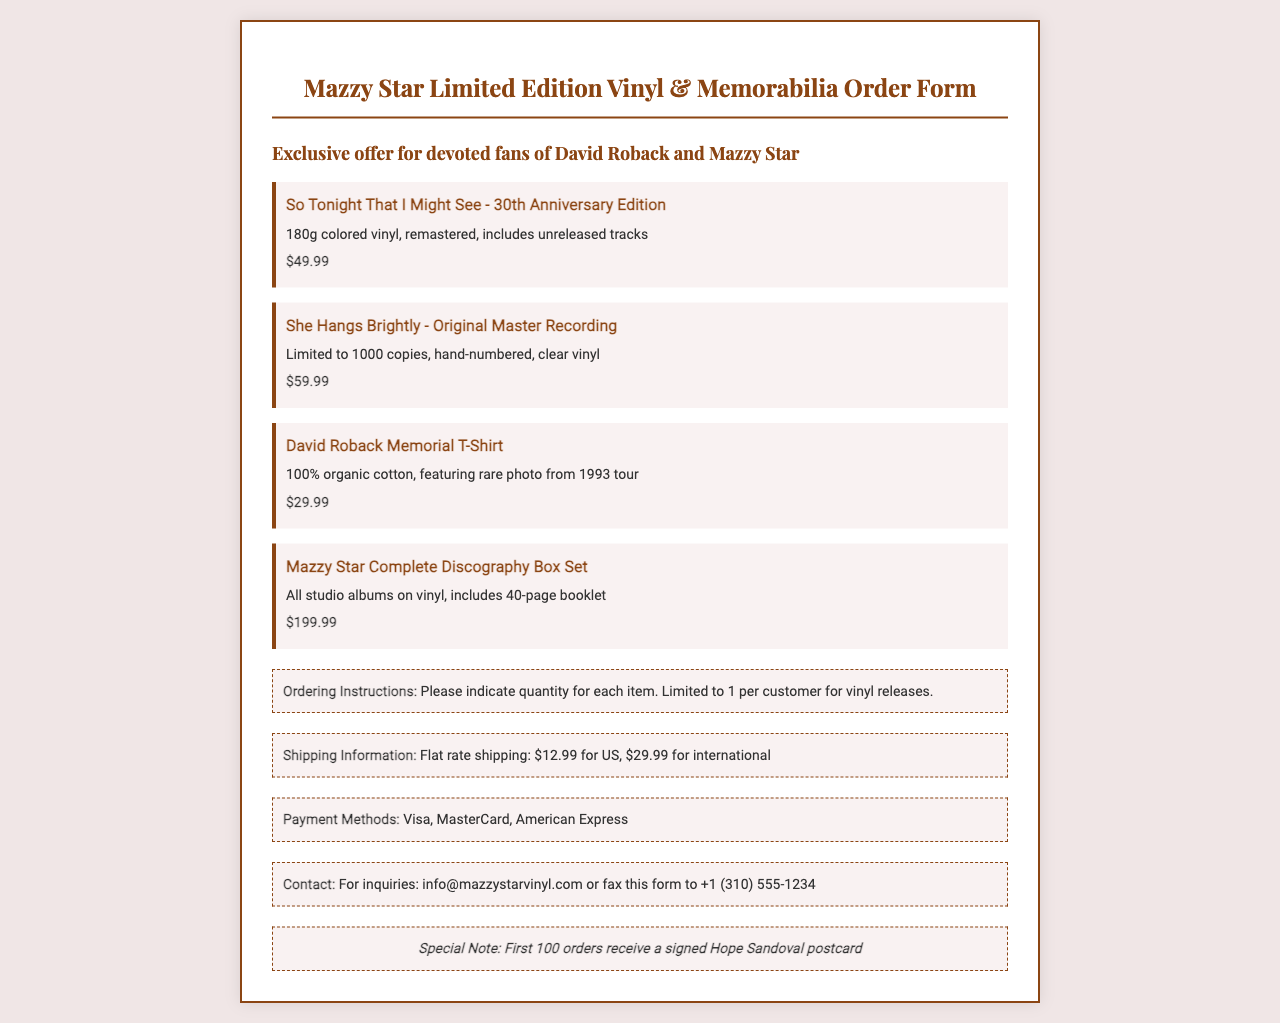What is the price of "So Tonight That I Might See" vinyl? The price is clearly listed next to the item description in the document.
Answer: $49.99 How many copies of "She Hangs Brightly" are available? The document states that this item is limited to 1000 copies.
Answer: 1000 What color is the vinyl for "So Tonight That I Might See"? The description specifies that it is 180g colored vinyl.
Answer: Colored What is included with the "Mazzy Star Complete Discography Box Set"? The description mentions that it includes all studio albums and a 40-page booklet.
Answer: All studio albums, 40-page booklet How much is the flat rate shipping for international orders? The shipping section specifies the international rate.
Answer: $29.99 What special offer is mentioned for the first 100 orders? The document outlines a special incentive for early orders.
Answer: Signed Hope Sandoval postcard Which payment methods are accepted? The payment section lists the accepted methods.
Answer: Visa, MasterCard, American Express What is the maximum quantity per customer for vinyl releases? The ordering instructions specify the limit for vinyl orders.
Answer: 1 per customer 